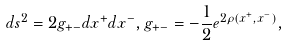Convert formula to latex. <formula><loc_0><loc_0><loc_500><loc_500>d s ^ { 2 } = 2 g _ { + - } d x ^ { + } d x ^ { - } , g _ { + - } = - \frac { 1 } { 2 } e ^ { 2 \rho ( x ^ { + } , x ^ { - } ) } ,</formula> 